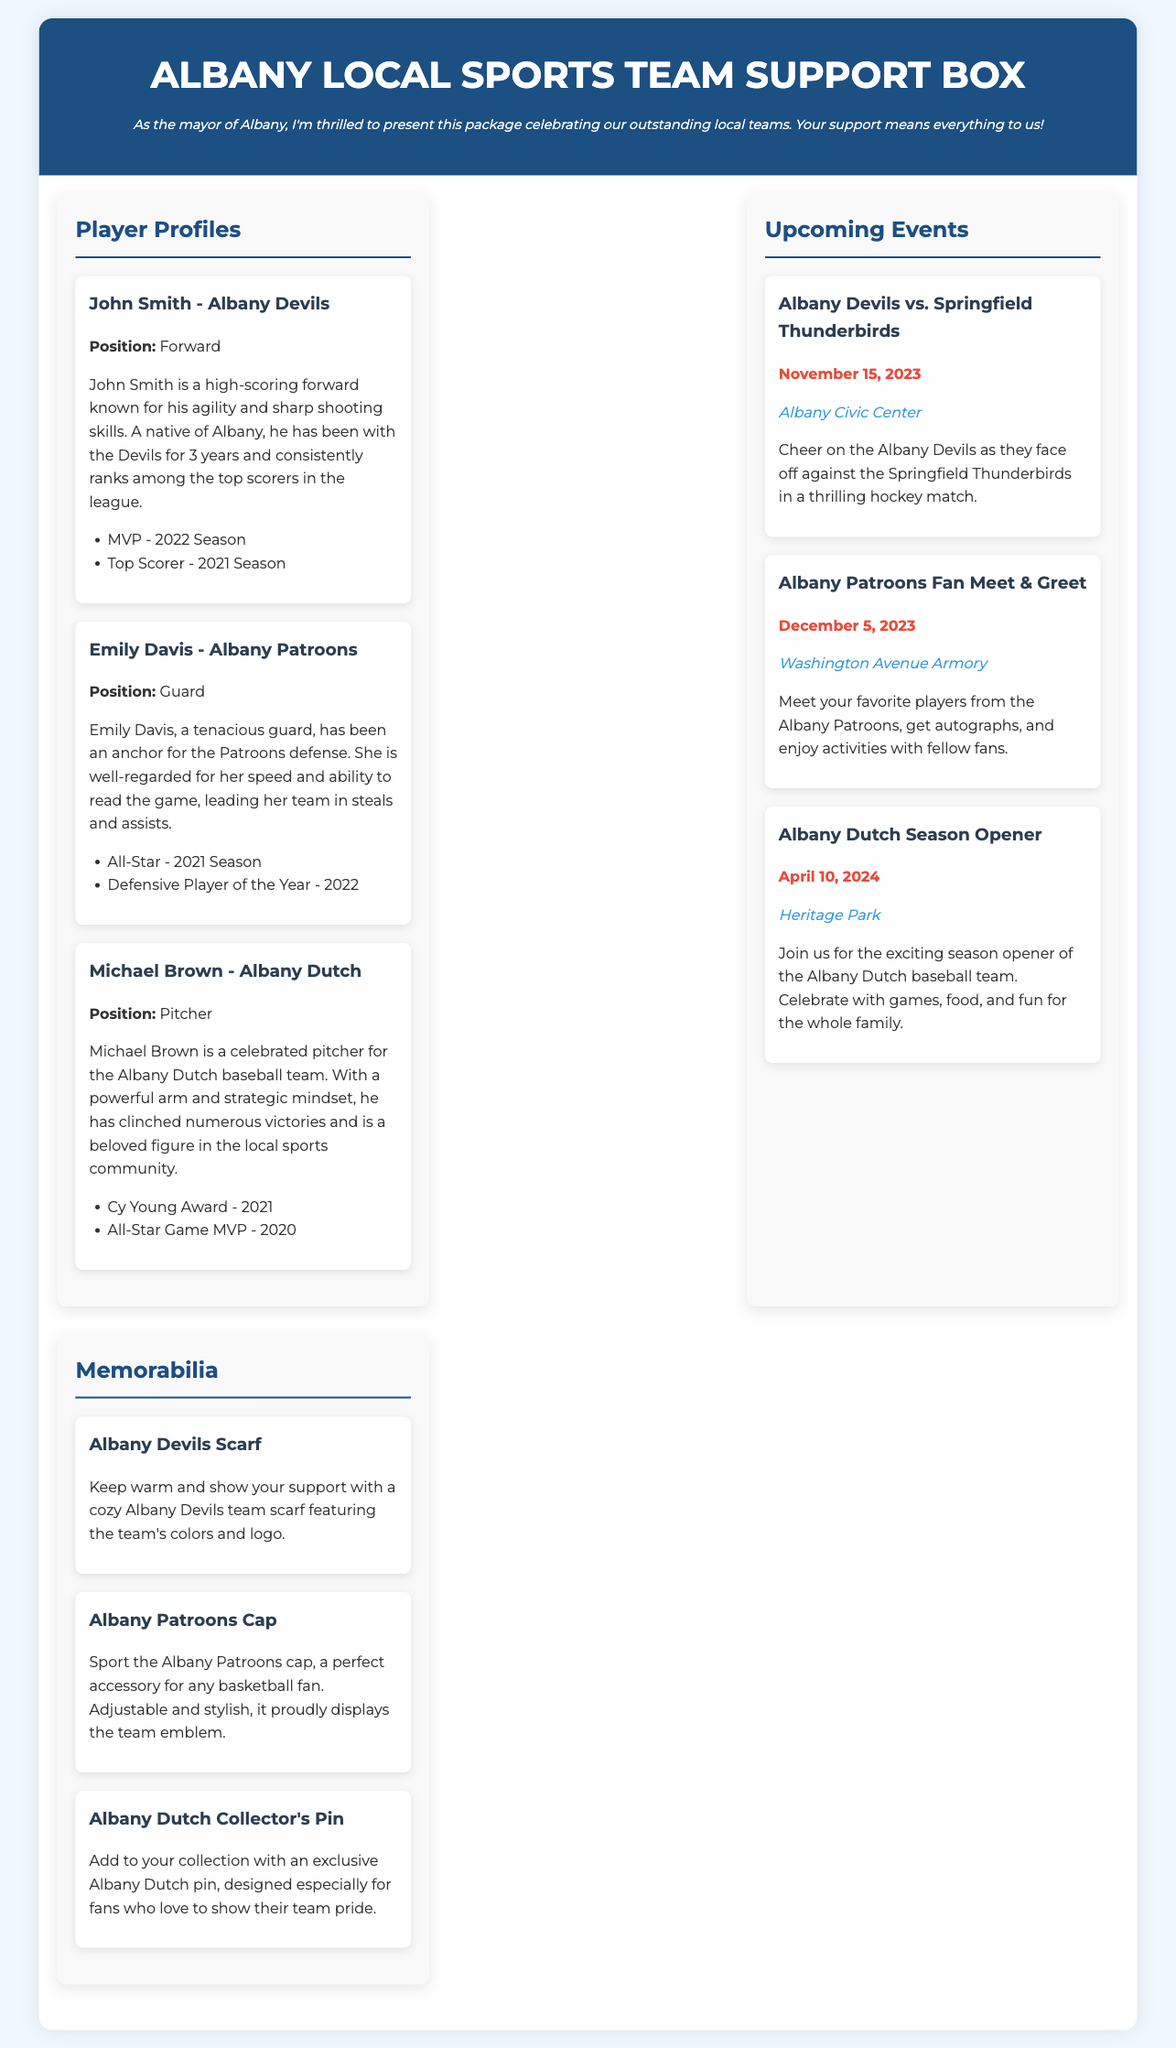what position does John Smith play? The document states that John Smith plays as a Forward for the Albany Devils.
Answer: Forward which award did Emily Davis receive in 2022? The document mentions that Emily Davis was awarded Defensive Player of the Year in 2022.
Answer: Defensive Player of the Year when is the Albany Devils game against the Springfield Thunderbirds? The upcoming event section indicates that the game is scheduled for November 15, 2023.
Answer: November 15, 2023 where will the Albany Patroons Fan Meet & Greet take place? The location for the Albany Patroons Fan Meet & Greet is indicated as the Washington Avenue Armory in the document.
Answer: Washington Avenue Armory what is the title of the document? The document has the title "Albany Local Sports Team Support Box".
Answer: Albany Local Sports Team Support Box what memorabilia item features the Albany Devils logo? The document describes the Albany Devils Scarf as featuring the team's colors and logo.
Answer: Albany Devils Scarf how many players are profiled in the document? The document includes profiles for three players: John Smith, Emily Davis, and Michael Brown.
Answer: three what is the date of the Albany Dutch season opener? The document notes that the Albany Dutch season opener is on April 10, 2024.
Answer: April 10, 2024 